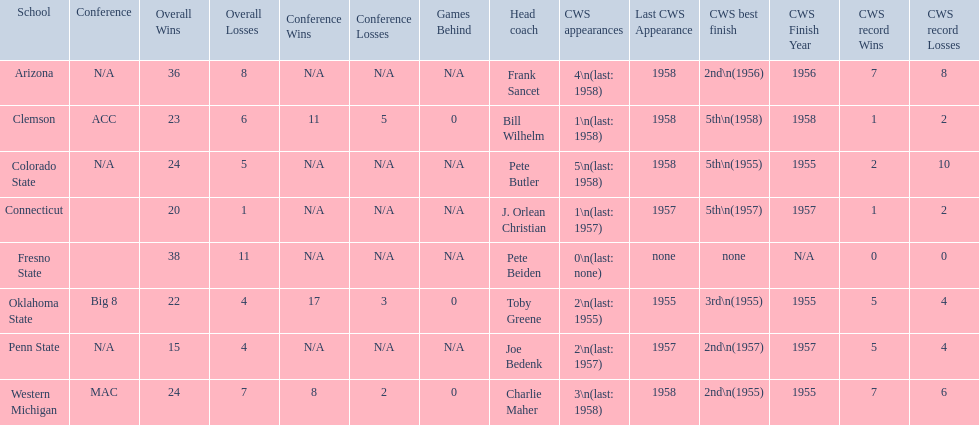What was the least amount of wins recorded by the losingest team? 15–4 (N/A). Which team held this record? Penn State. 